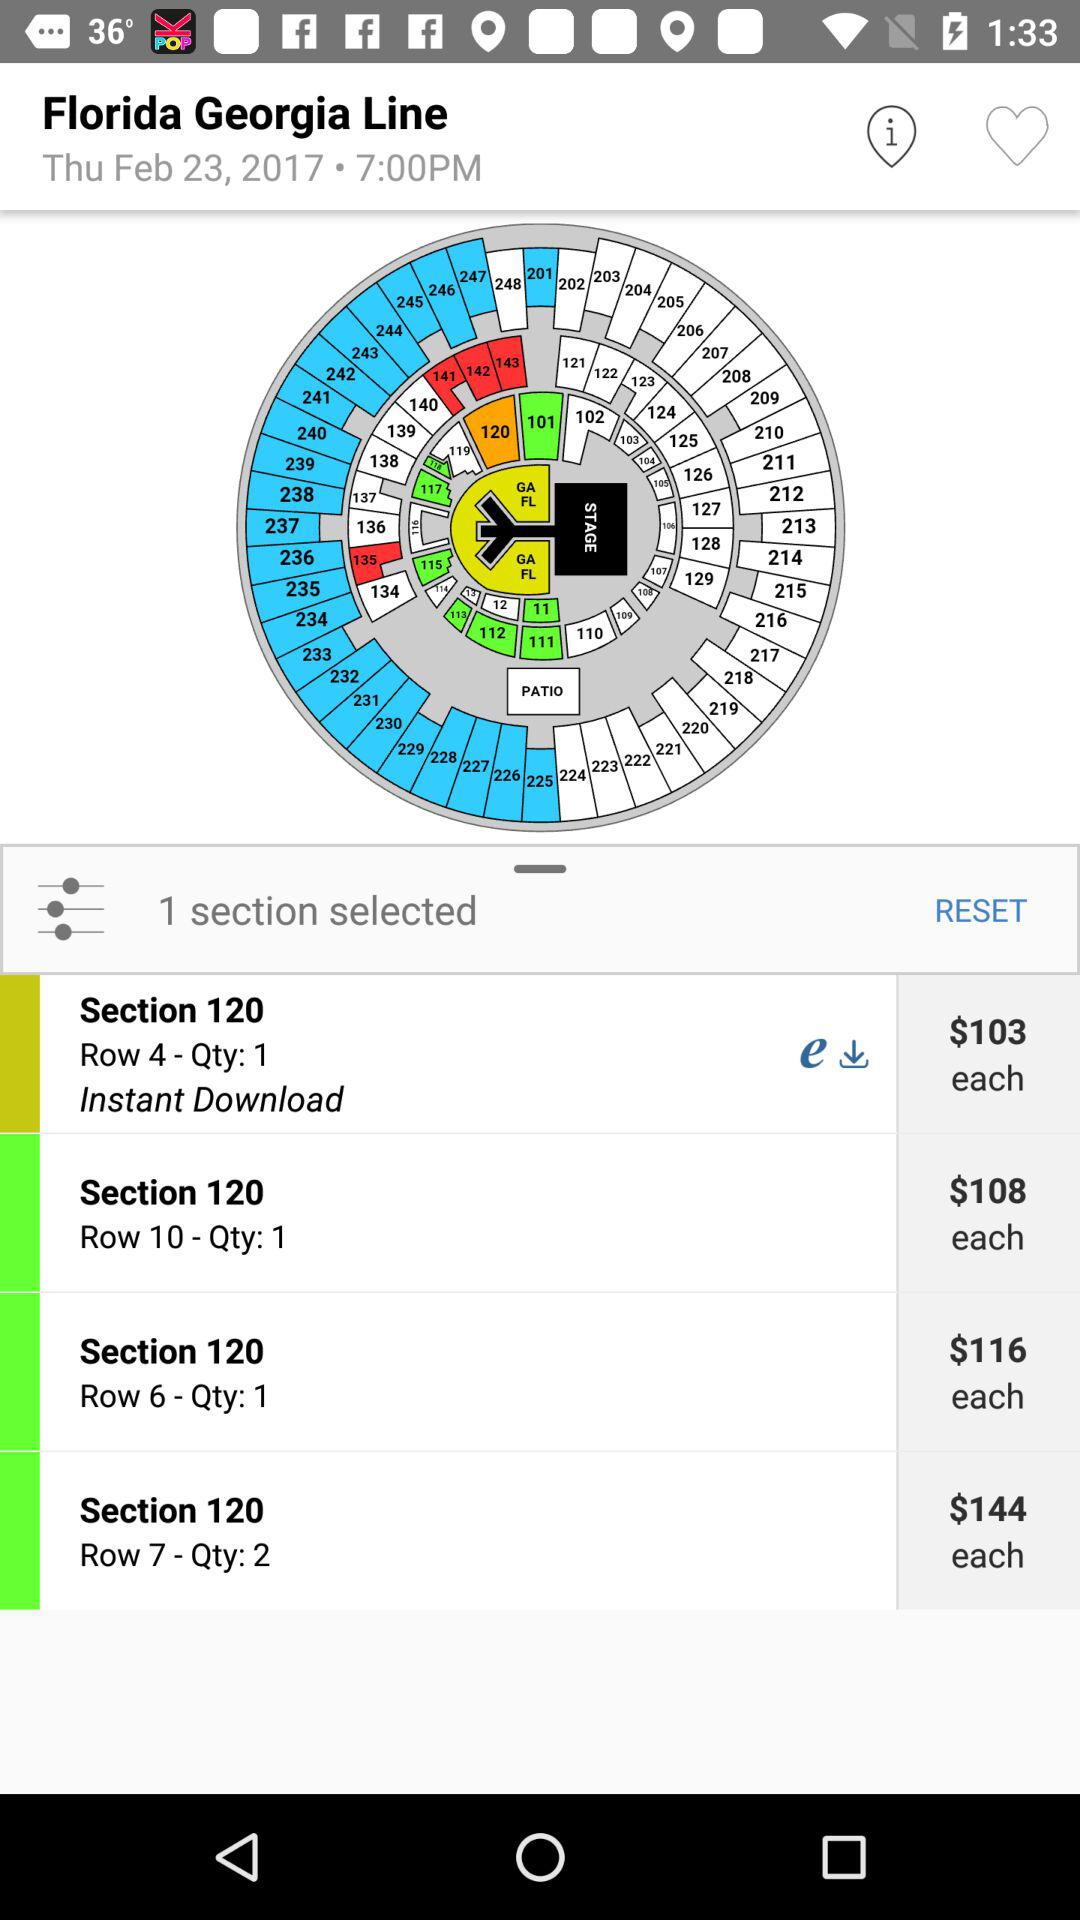What musical duo is given on the screen? The given musical duo is Florida Georgia Line. 